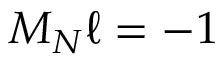<formula> <loc_0><loc_0><loc_500><loc_500>M _ { N } \ell = - 1</formula> 